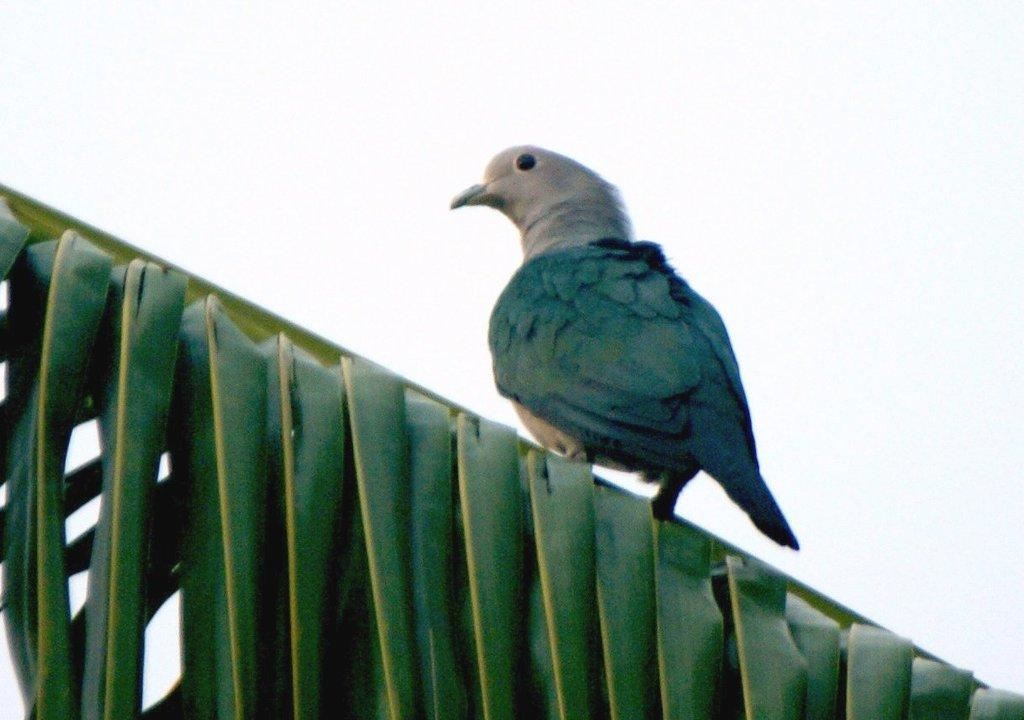What type of animal can be seen in the image? There is a bird in the image. Where is the bird located? The bird is on a leaf. What can be seen in the background of the image? There is sky visible in the background of the image. What type of ornament is hanging from the bird's beak in the image? There is no ornament hanging from the bird's beak in the image; the bird is simply perched on a leaf. 